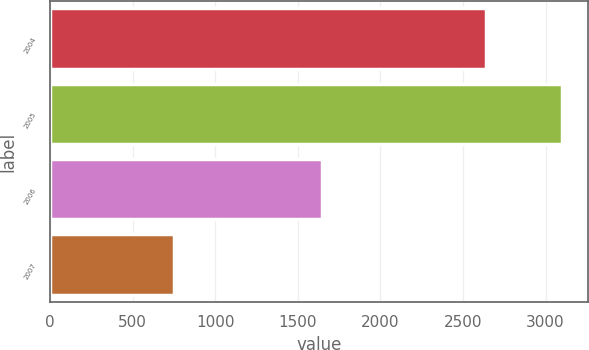Convert chart. <chart><loc_0><loc_0><loc_500><loc_500><bar_chart><fcel>2004<fcel>2005<fcel>2006<fcel>2007<nl><fcel>2637<fcel>3101<fcel>1648<fcel>749<nl></chart> 